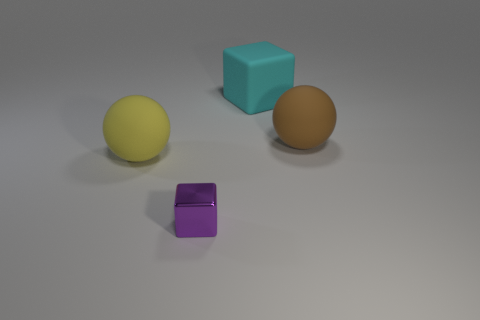Add 3 cyan blocks. How many objects exist? 7 Subtract all red metallic blocks. Subtract all cubes. How many objects are left? 2 Add 1 large spheres. How many large spheres are left? 3 Add 2 small purple things. How many small purple things exist? 3 Subtract 1 purple blocks. How many objects are left? 3 